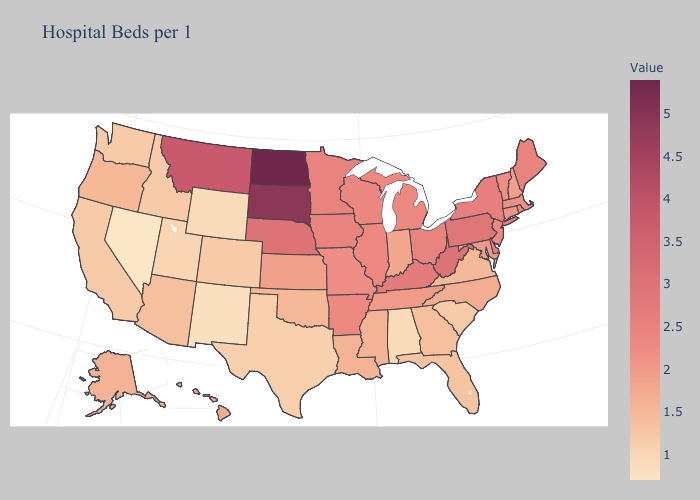Does Kentucky have the highest value in the South?
Be succinct. No. Which states have the lowest value in the USA?
Keep it brief. Nevada. Which states have the highest value in the USA?
Give a very brief answer. North Dakota. Which states hav the highest value in the Northeast?
Be succinct. Pennsylvania. 